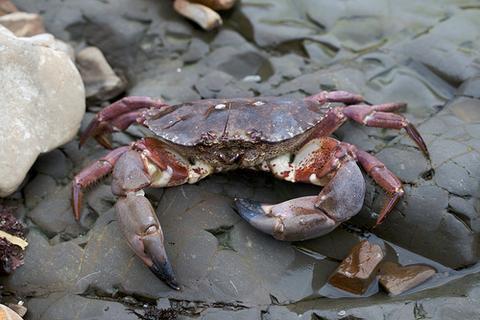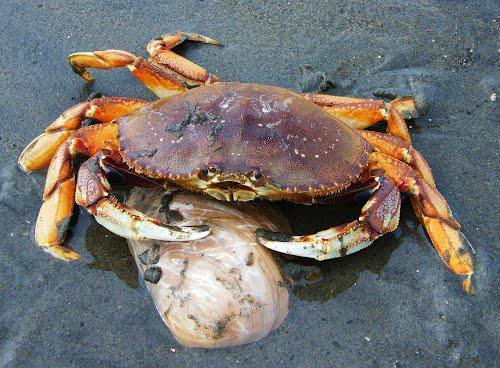The first image is the image on the left, the second image is the image on the right. Analyze the images presented: Is the assertion "Someone is holding the crab in the image on the right." valid? Answer yes or no. No. The first image is the image on the left, the second image is the image on the right. Assess this claim about the two images: "The left image features one hand holding a forward-facing crab in front of a body of water.". Correct or not? Answer yes or no. No. 